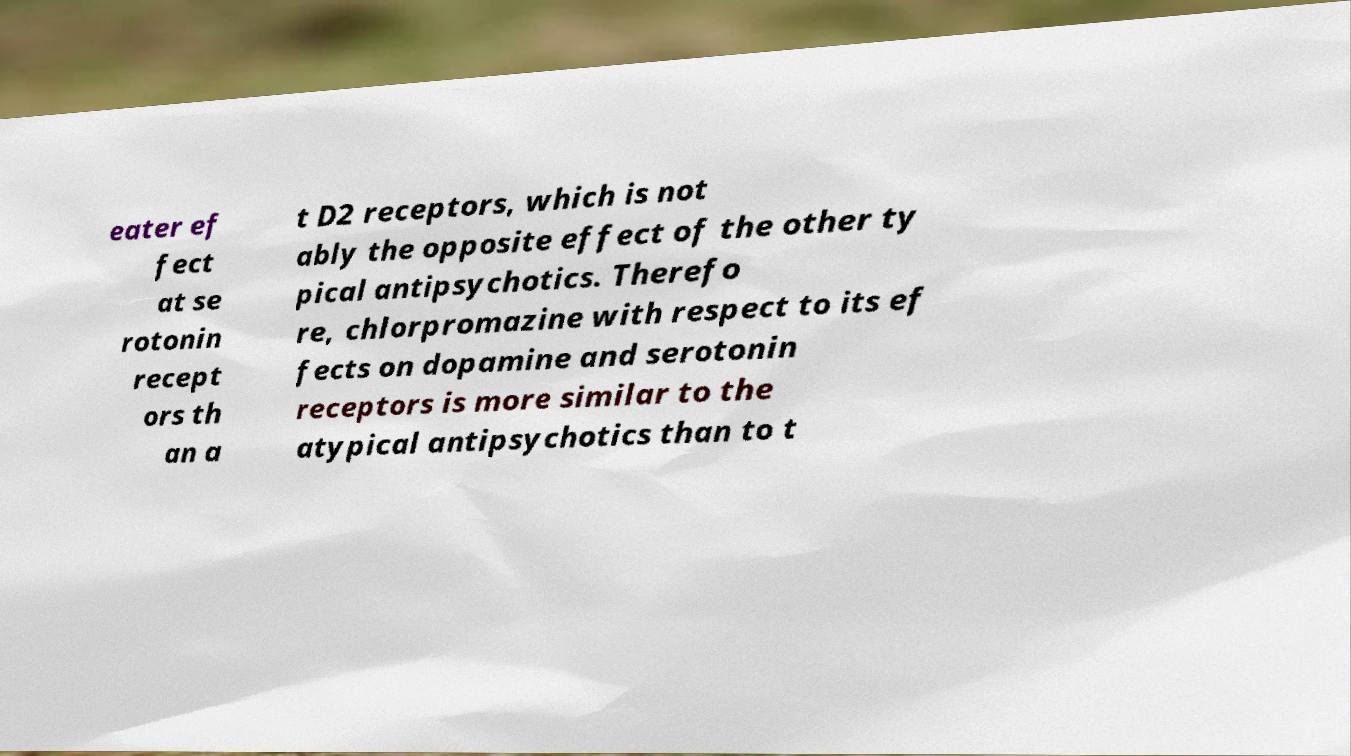Could you assist in decoding the text presented in this image and type it out clearly? eater ef fect at se rotonin recept ors th an a t D2 receptors, which is not ably the opposite effect of the other ty pical antipsychotics. Therefo re, chlorpromazine with respect to its ef fects on dopamine and serotonin receptors is more similar to the atypical antipsychotics than to t 